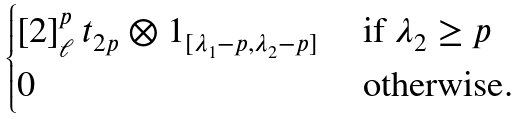<formula> <loc_0><loc_0><loc_500><loc_500>\begin{cases} [ 2 ] _ { \ell } ^ { p } \, { t _ { 2 p } } \otimes 1 _ { [ \lambda _ { 1 } - p , \lambda _ { 2 } - p ] } & \text { if } \lambda _ { 2 } \geq p \\ 0 & \text { otherwise.} \end{cases}</formula> 